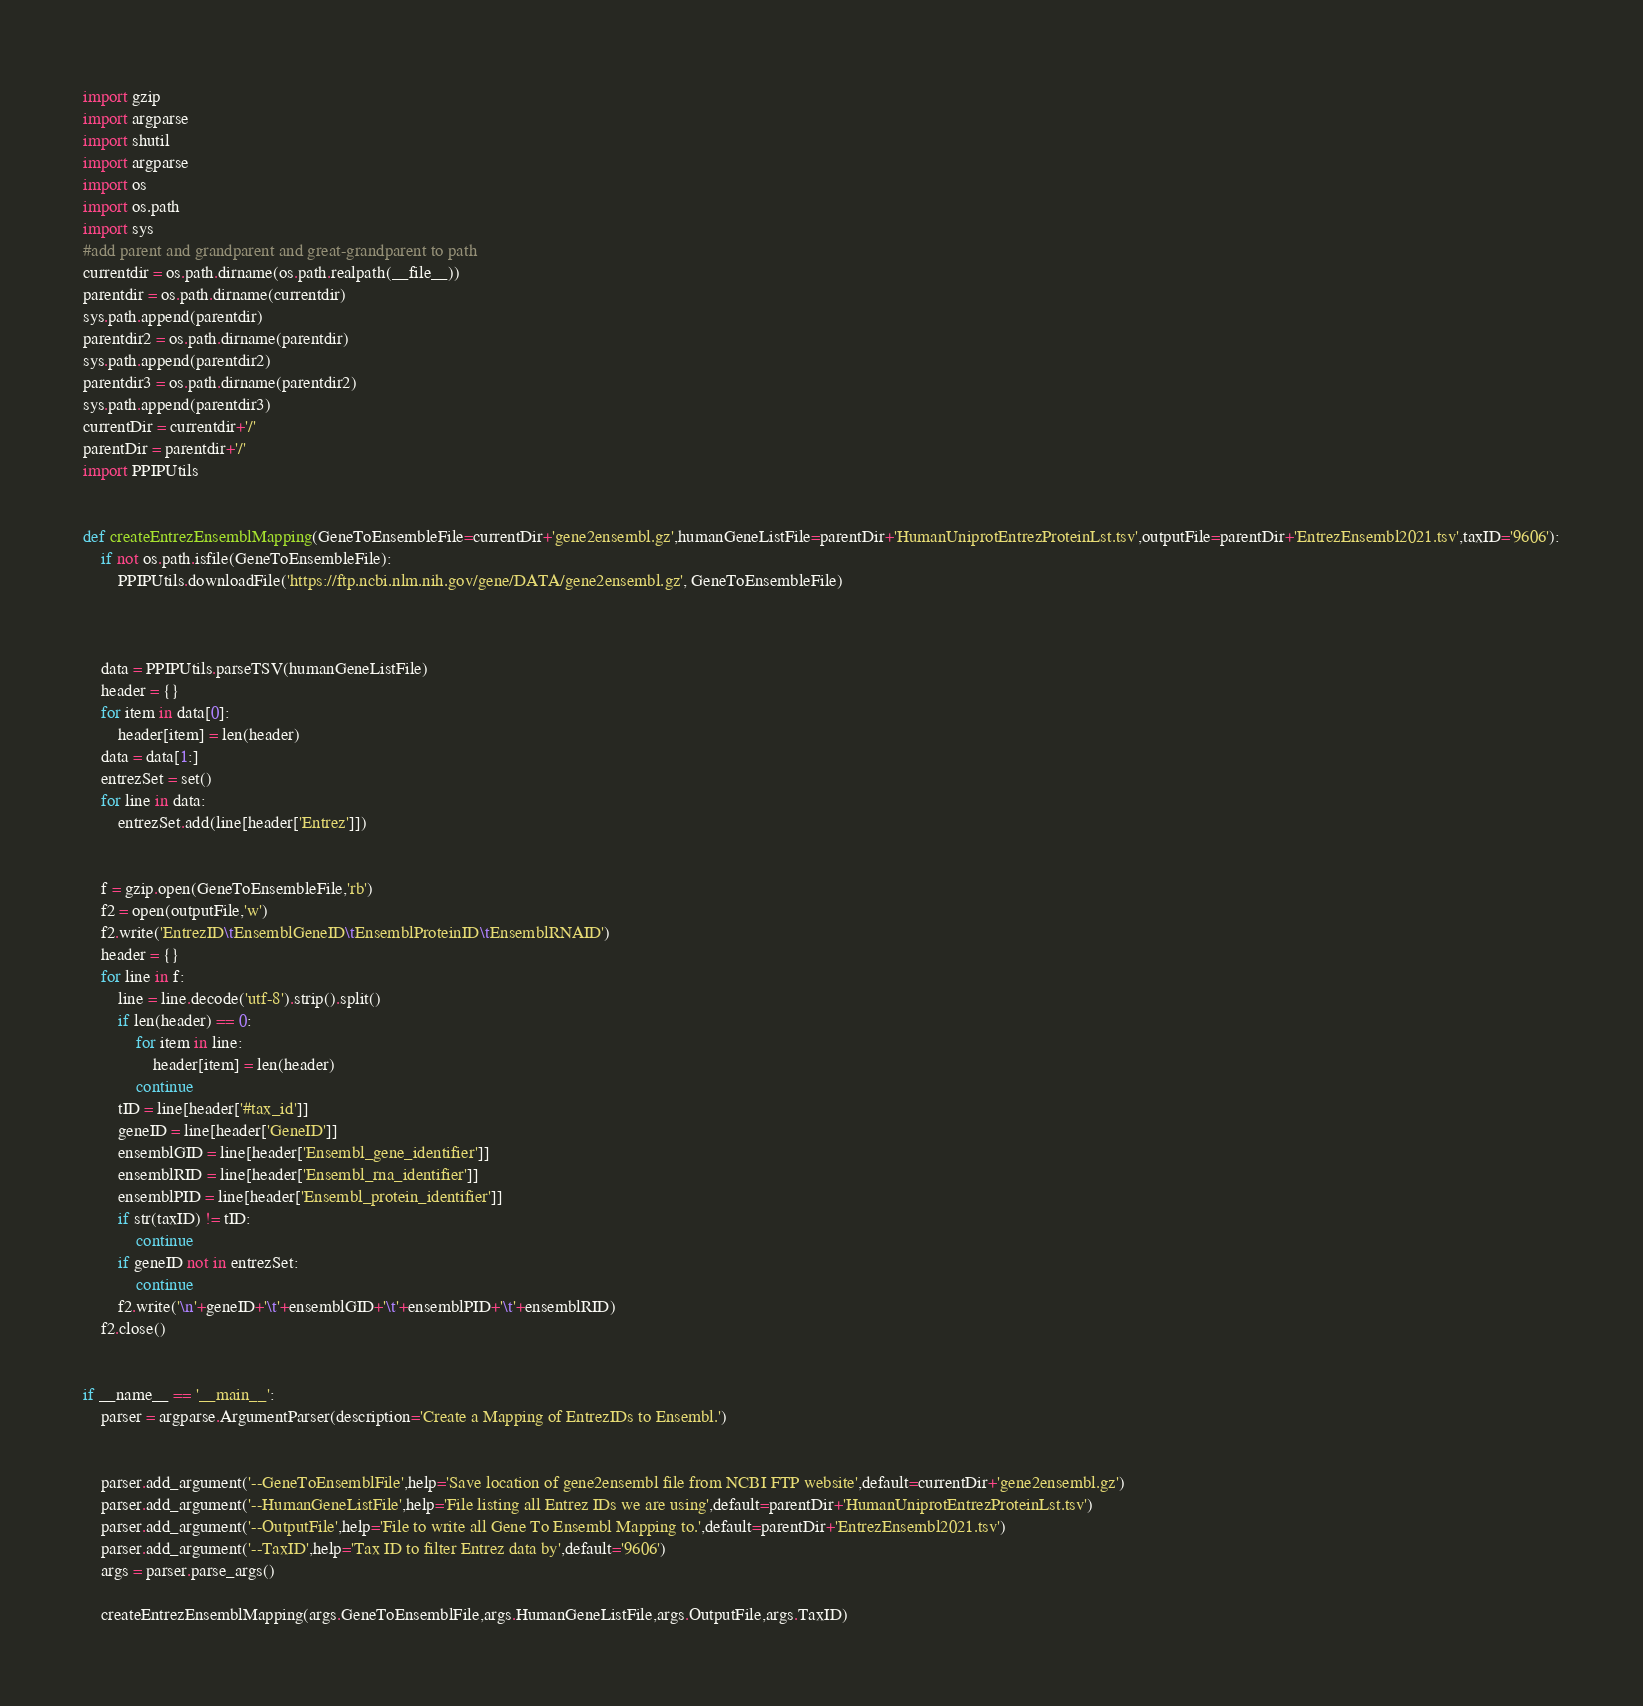Convert code to text. <code><loc_0><loc_0><loc_500><loc_500><_Python_>import gzip
import argparse
import shutil
import argparse
import os
import os.path
import sys
#add parent and grandparent and great-grandparent to path
currentdir = os.path.dirname(os.path.realpath(__file__))
parentdir = os.path.dirname(currentdir)
sys.path.append(parentdir)
parentdir2 = os.path.dirname(parentdir)
sys.path.append(parentdir2)
parentdir3 = os.path.dirname(parentdir2)
sys.path.append(parentdir3)
currentDir = currentdir+'/'
parentDir = parentdir+'/'
import PPIPUtils


def createEntrezEnsemblMapping(GeneToEnsembleFile=currentDir+'gene2ensembl.gz',humanGeneListFile=parentDir+'HumanUniprotEntrezProteinLst.tsv',outputFile=parentDir+'EntrezEnsembl2021.tsv',taxID='9606'):
	if not os.path.isfile(GeneToEnsembleFile):
		PPIPUtils.downloadFile('https://ftp.ncbi.nlm.nih.gov/gene/DATA/gene2ensembl.gz', GeneToEnsembleFile)
				


	data = PPIPUtils.parseTSV(humanGeneListFile)
	header = {}
	for item in data[0]:
		header[item] = len(header)
	data = data[1:]
	entrezSet = set()
	for line in data:
		entrezSet.add(line[header['Entrez']])
	
	
	f = gzip.open(GeneToEnsembleFile,'rb')
	f2 = open(outputFile,'w')
	f2.write('EntrezID\tEnsemblGeneID\tEnsemblProteinID\tEnsemblRNAID')
	header = {}
	for line in f:
		line = line.decode('utf-8').strip().split()
		if len(header) == 0:
			for item in line:
				header[item] = len(header)
			continue
		tID = line[header['#tax_id']]
		geneID = line[header['GeneID']]
		ensemblGID = line[header['Ensembl_gene_identifier']]
		ensemblRID = line[header['Ensembl_rna_identifier']]
		ensemblPID = line[header['Ensembl_protein_identifier']]
		if str(taxID) != tID:
			continue
		if geneID not in entrezSet:
			continue
		f2.write('\n'+geneID+'\t'+ensemblGID+'\t'+ensemblPID+'\t'+ensemblRID)
	f2.close()
	
		
if __name__ == '__main__':
	parser = argparse.ArgumentParser(description='Create a Mapping of EntrezIDs to Ensembl.')
	
	
	parser.add_argument('--GeneToEnsemblFile',help='Save location of gene2ensembl file from NCBI FTP website',default=currentDir+'gene2ensembl.gz')
	parser.add_argument('--HumanGeneListFile',help='File listing all Entrez IDs we are using',default=parentDir+'HumanUniprotEntrezProteinLst.tsv')
	parser.add_argument('--OutputFile',help='File to write all Gene To Ensembl Mapping to.',default=parentDir+'EntrezEnsembl2021.tsv')
	parser.add_argument('--TaxID',help='Tax ID to filter Entrez data by',default='9606')
	args = parser.parse_args()

	createEntrezEnsemblMapping(args.GeneToEnsemblFile,args.HumanGeneListFile,args.OutputFile,args.TaxID)</code> 